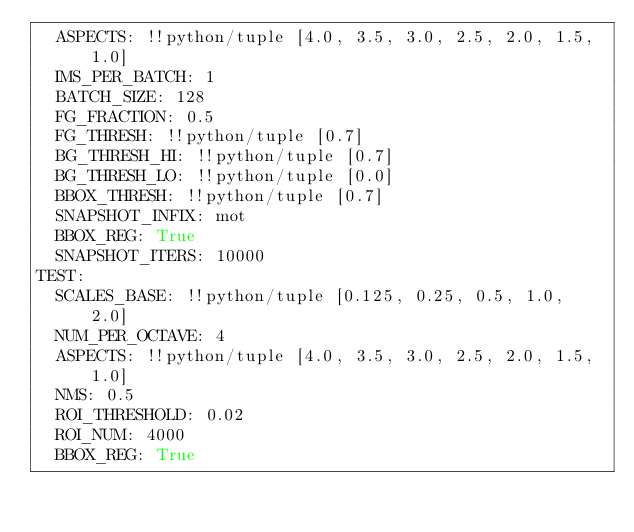Convert code to text. <code><loc_0><loc_0><loc_500><loc_500><_YAML_>  ASPECTS: !!python/tuple [4.0, 3.5, 3.0, 2.5, 2.0, 1.5, 1.0]
  IMS_PER_BATCH: 1
  BATCH_SIZE: 128
  FG_FRACTION: 0.5
  FG_THRESH: !!python/tuple [0.7]
  BG_THRESH_HI: !!python/tuple [0.7]
  BG_THRESH_LO: !!python/tuple [0.0]
  BBOX_THRESH: !!python/tuple [0.7]
  SNAPSHOT_INFIX: mot
  BBOX_REG: True
  SNAPSHOT_ITERS: 10000
TEST:
  SCALES_BASE: !!python/tuple [0.125, 0.25, 0.5, 1.0, 2.0]
  NUM_PER_OCTAVE: 4
  ASPECTS: !!python/tuple [4.0, 3.5, 3.0, 2.5, 2.0, 1.5, 1.0]
  NMS: 0.5
  ROI_THRESHOLD: 0.02
  ROI_NUM: 4000
  BBOX_REG: True
</code> 